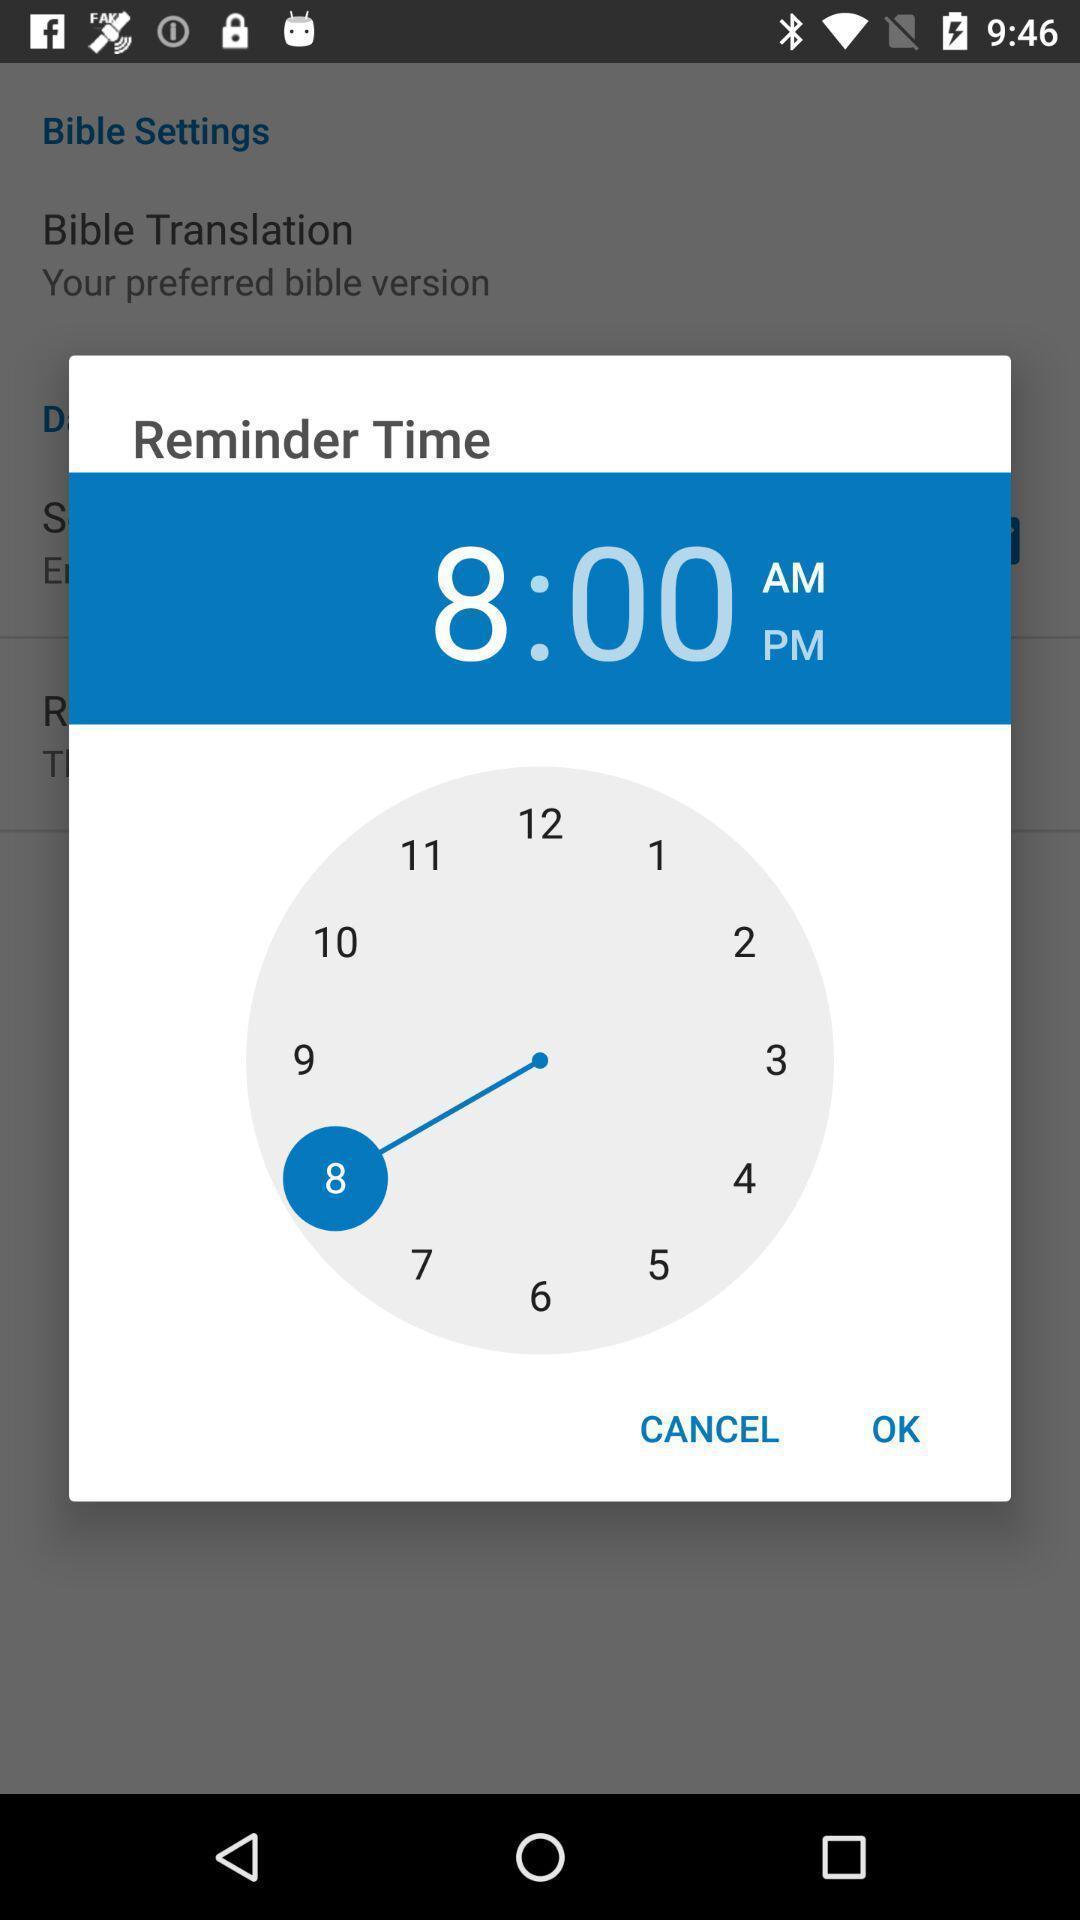Explain the elements present in this screenshot. Pop-up display showing reminder time. 